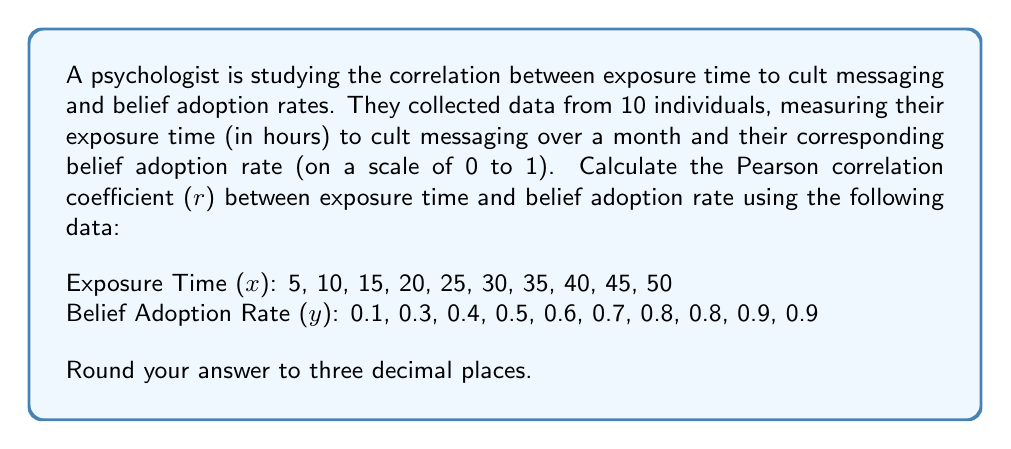Give your solution to this math problem. To calculate the Pearson correlation coefficient (r), we'll use the formula:

$$ r = \frac{n\sum xy - \sum x \sum y}{\sqrt{[n\sum x^2 - (\sum x)^2][n\sum y^2 - (\sum y)^2]}} $$

Where:
n = number of data points
x = exposure time
y = belief adoption rate

Step 1: Calculate the required sums:
$\sum x = 275$
$\sum y = 6.0$
$\sum xy = 196.5$
$\sum x^2 = 9625$
$\sum y^2 = 4.26$

Step 2: Calculate $n\sum xy$ and $\sum x \sum y$:
$n\sum xy = 10 \times 196.5 = 1965$
$\sum x \sum y = 275 \times 6.0 = 1650$

Step 3: Calculate the numerator:
$n\sum xy - \sum x \sum y = 1965 - 1650 = 315$

Step 4: Calculate the denominator components:
$n\sum x^2 - (\sum x)^2 = 10 \times 9625 - 275^2 = 20625$
$n\sum y^2 - (\sum y)^2 = 10 \times 4.26 - 6.0^2 = 6.6$

Step 5: Calculate the denominator:
$\sqrt{[n\sum x^2 - (\sum x)^2][n\sum y^2 - (\sum y)^2]} = \sqrt{20625 \times 6.6} = \sqrt{136125} \approx 368.951$

Step 6: Calculate the correlation coefficient:
$r = \frac{315}{368.951} \approx 0.854$

Round to three decimal places: 0.854
Answer: 0.854 